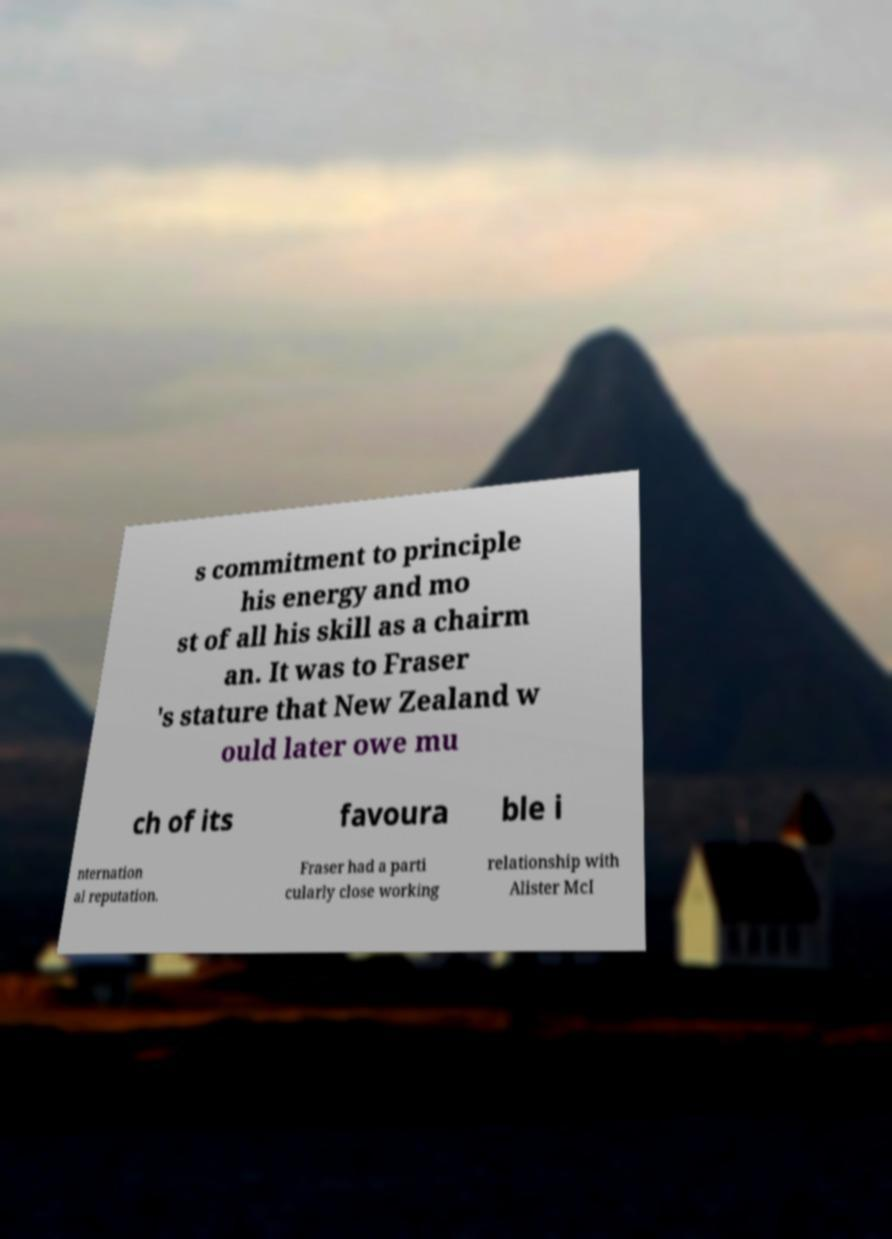What messages or text are displayed in this image? I need them in a readable, typed format. s commitment to principle his energy and mo st of all his skill as a chairm an. It was to Fraser 's stature that New Zealand w ould later owe mu ch of its favoura ble i nternation al reputation. Fraser had a parti cularly close working relationship with Alister McI 